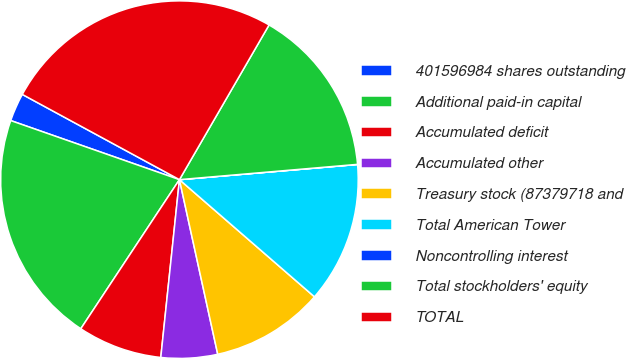Convert chart to OTSL. <chart><loc_0><loc_0><loc_500><loc_500><pie_chart><fcel>401596984 shares outstanding<fcel>Additional paid-in capital<fcel>Accumulated deficit<fcel>Accumulated other<fcel>Treasury stock (87379718 and<fcel>Total American Tower<fcel>Noncontrolling interest<fcel>Total stockholders' equity<fcel>TOTAL<nl><fcel>2.55%<fcel>21.06%<fcel>7.64%<fcel>5.1%<fcel>10.19%<fcel>12.73%<fcel>0.01%<fcel>15.28%<fcel>25.45%<nl></chart> 